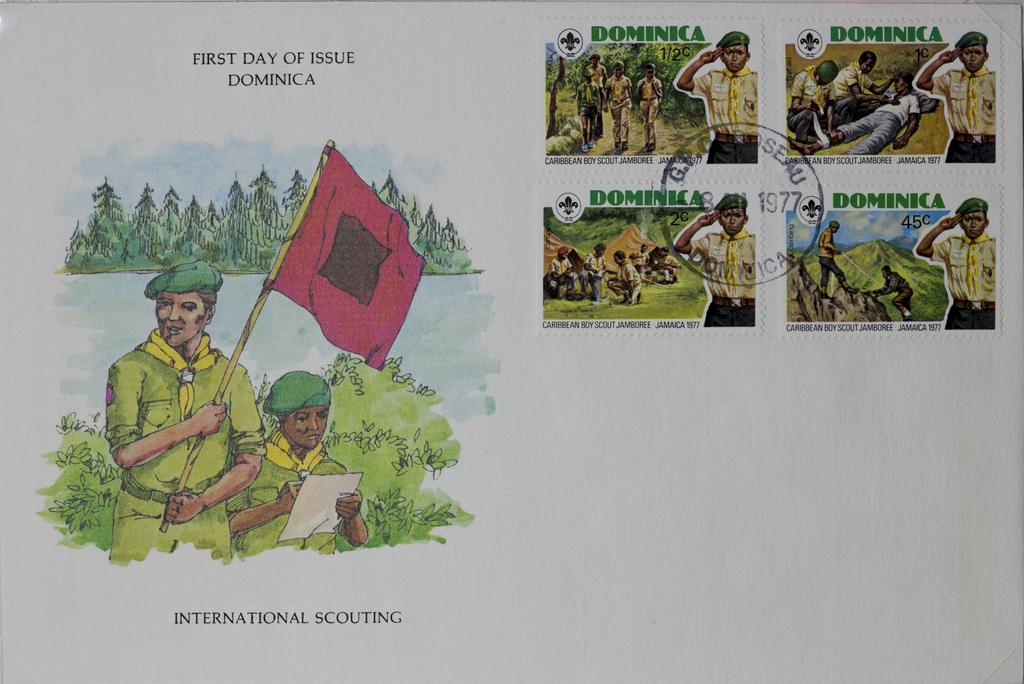<image>
Present a compact description of the photo's key features. a paper that says 'first day of issue dominca' 